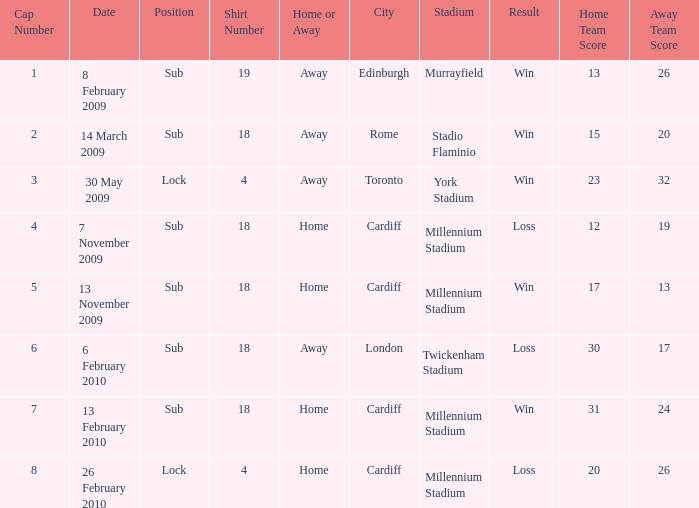Can you tell me the lowest Cap Number that has the Date of 8 february 2009, and the Shirt Number larger than 19? None. 